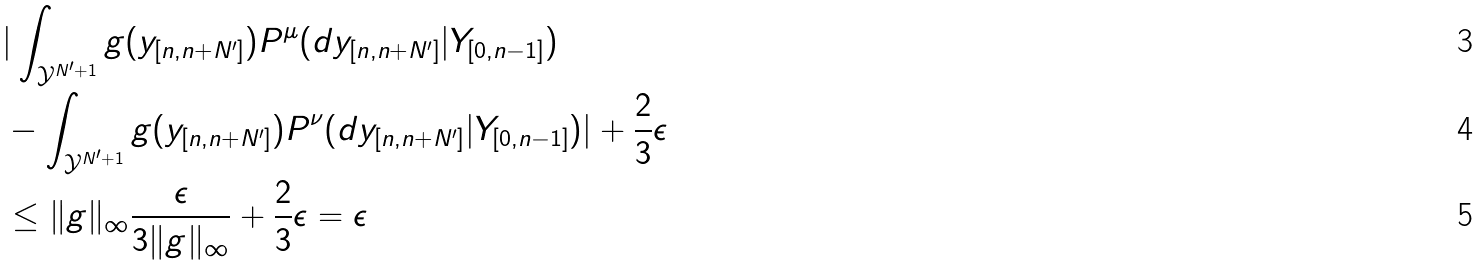Convert formula to latex. <formula><loc_0><loc_0><loc_500><loc_500>& | \int _ { \mathcal { Y } ^ { N ^ { \prime } + 1 } } g ( y _ { [ n , n + N ^ { \prime } ] } ) P ^ { \mu } ( d y _ { [ n , n + N ^ { \prime } ] } | Y _ { [ 0 , n - 1 ] } ) \\ & - \int _ { \mathcal { Y } ^ { N ^ { \prime } + 1 } } g ( y _ { [ n , n + N ^ { \prime } ] } ) P ^ { \nu } ( d y _ { [ n , n + N ^ { \prime } ] } | Y _ { [ 0 , n - 1 ] } ) | + \frac { 2 } { 3 } \epsilon \\ & \leq \| g \| _ { \infty } \frac { \epsilon } { 3 \| g \| _ { \infty } } + \frac { 2 } { 3 } \epsilon = \epsilon</formula> 